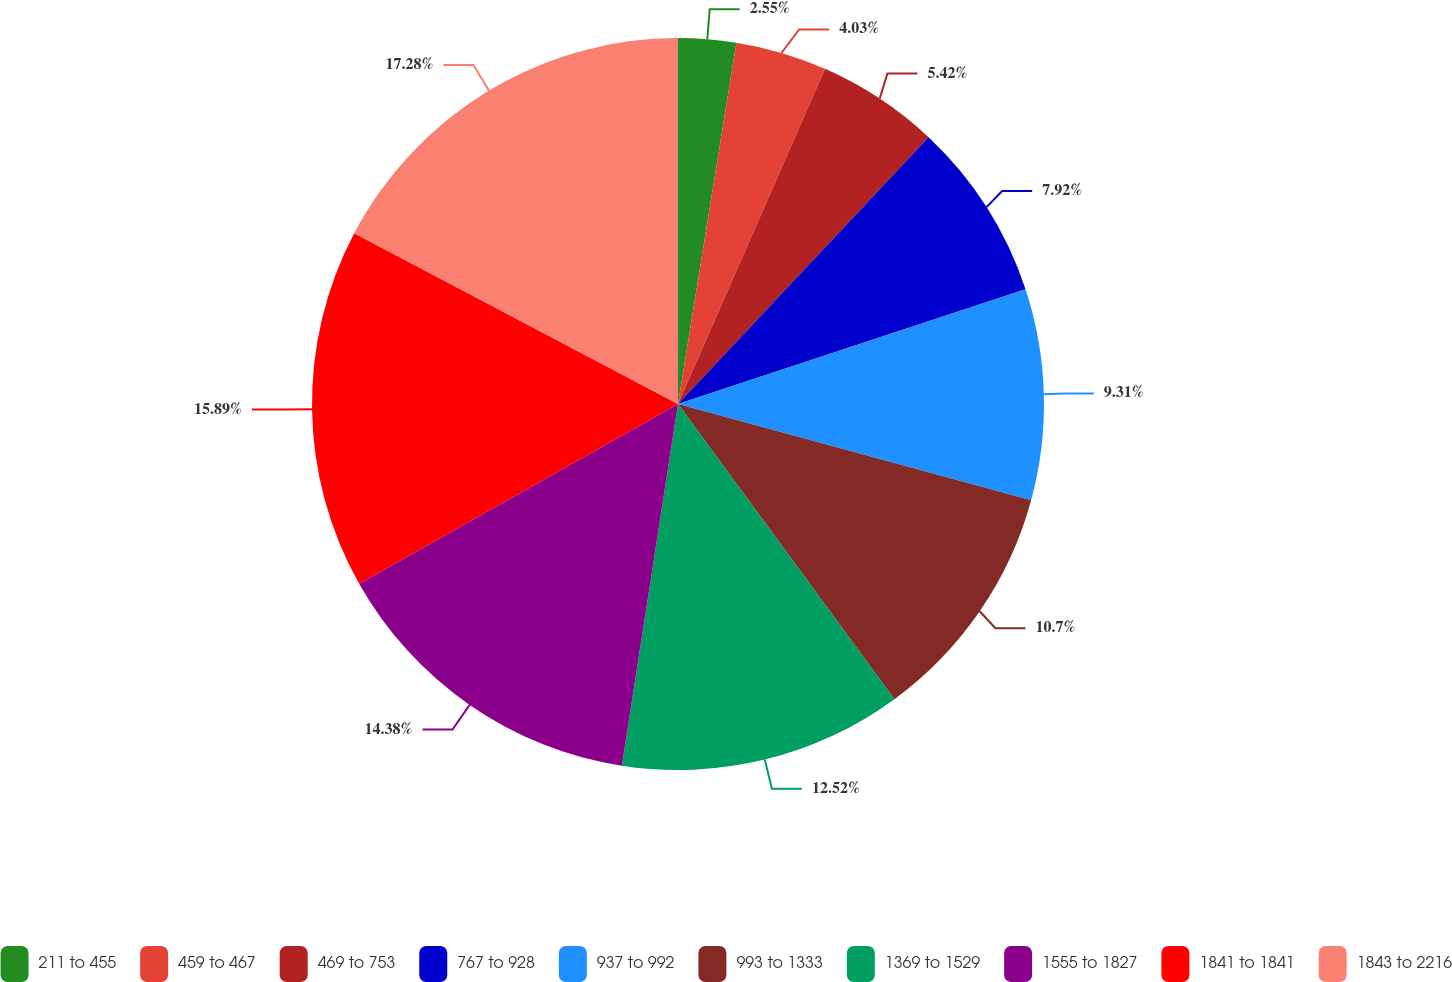<chart> <loc_0><loc_0><loc_500><loc_500><pie_chart><fcel>211 to 455<fcel>459 to 467<fcel>469 to 753<fcel>767 to 928<fcel>937 to 992<fcel>993 to 1333<fcel>1369 to 1529<fcel>1555 to 1827<fcel>1841 to 1841<fcel>1843 to 2216<nl><fcel>2.55%<fcel>4.03%<fcel>5.42%<fcel>7.92%<fcel>9.31%<fcel>10.7%<fcel>12.52%<fcel>14.38%<fcel>15.89%<fcel>17.28%<nl></chart> 